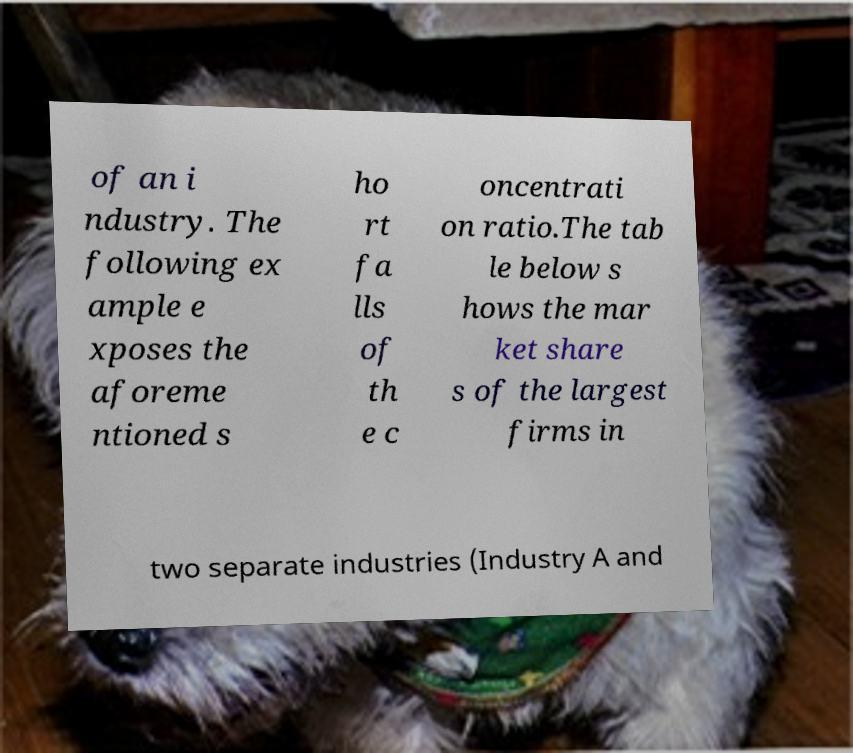Please identify and transcribe the text found in this image. of an i ndustry. The following ex ample e xposes the aforeme ntioned s ho rt fa lls of th e c oncentrati on ratio.The tab le below s hows the mar ket share s of the largest firms in two separate industries (Industry A and 